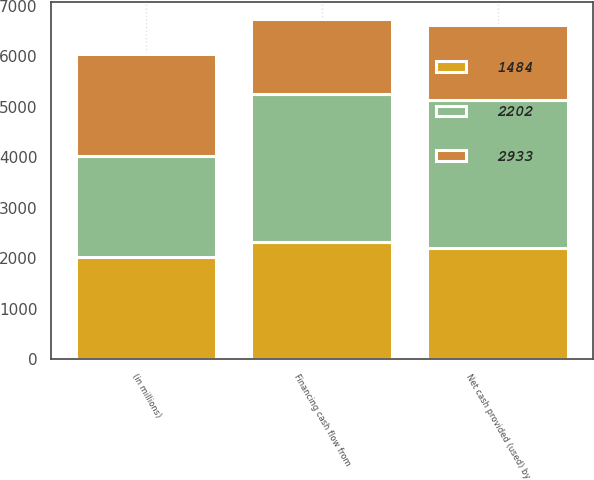Convert chart to OTSL. <chart><loc_0><loc_0><loc_500><loc_500><stacked_bar_chart><ecel><fcel>(in millions)<fcel>Financing cash flow from<fcel>Net cash provided (used) by<nl><fcel>2933<fcel>2015<fcel>1484<fcel>1484<nl><fcel>1484<fcel>2014<fcel>2326<fcel>2202<nl><fcel>2202<fcel>2013<fcel>2933<fcel>2933<nl></chart> 